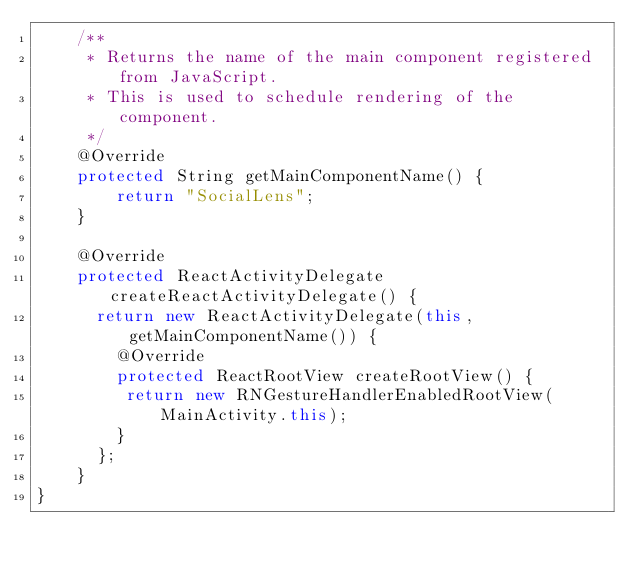<code> <loc_0><loc_0><loc_500><loc_500><_Java_>    /**
     * Returns the name of the main component registered from JavaScript.
     * This is used to schedule rendering of the component.
     */
    @Override
    protected String getMainComponentName() {
        return "SocialLens";
    }

    @Override
    protected ReactActivityDelegate createReactActivityDelegate() {
      return new ReactActivityDelegate(this, getMainComponentName()) {
        @Override
        protected ReactRootView createRootView() {
         return new RNGestureHandlerEnabledRootView(MainActivity.this);
        }
      };
    }
}
</code> 